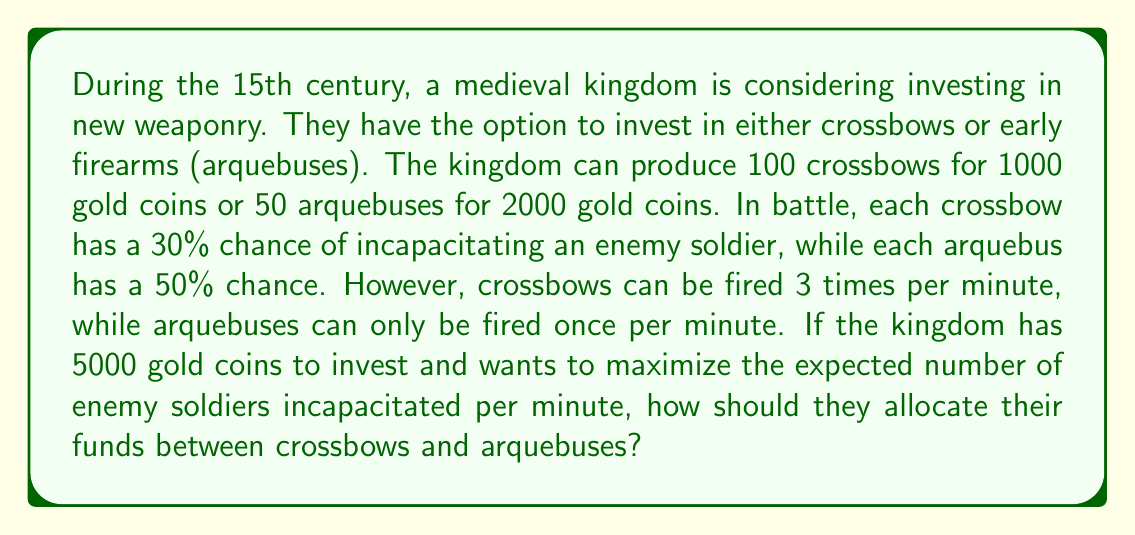Can you solve this math problem? Let's approach this problem step by step:

1) First, let's define our variables:
   $x$ = number of crossbows
   $y$ = number of arquebuses

2) We can set up our constraints:
   Cost constraint: $10x + 40y \leq 5000$ (since each crossbow costs 10 gold and each arquebus costs 40 gold)
   Non-negativity: $x \geq 0$, $y \geq 0$

3) Now, let's calculate the expected number of incapacitations per minute for each weapon:
   Crossbow: $0.30 \times 3 = 0.90$ incapacitations per minute
   Arquebus: $0.50 \times 1 = 0.50$ incapacitations per minute

4) Our objective function (to maximize) is:
   $Z = 0.90x + 0.50y$

5) This is a linear programming problem. We can solve it graphically or using the simplex method. Let's use the graphical method:

6) Plot the constraint: $10x + 40y = 5000$
   Intercepts: (500, 0) and (0, 125)

7) The feasible region is the triangle bounded by this line and the axes.

8) To find the optimal solution, we need to compare the slope of the objective function line ($-\frac{0.90}{0.50} = -1.8$) with the slope of the constraint line ($-\frac{10}{40} = -0.25$).

9) Since the slope of the objective function line is steeper, the optimal solution will be at the x-intercept of the constraint line.

10) This point is (500, 0), meaning the optimal solution is to produce 500 crossbows and 0 arquebuses.
Answer: The kingdom should invest all 5000 gold coins in crossbows, producing 500 crossbows and 0 arquebuses. This will maximize the expected number of enemy soldiers incapacitated per minute at $0.90 \times 500 = 450$. 